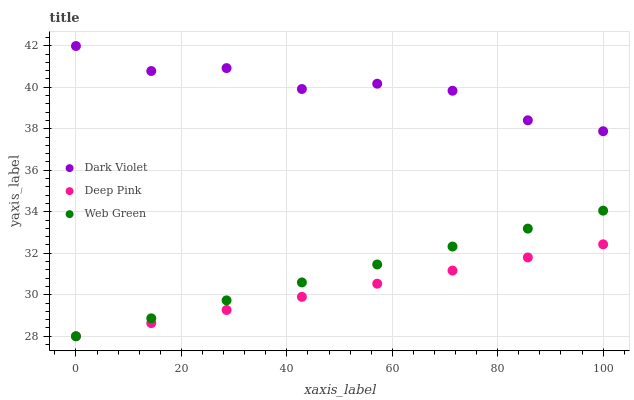Does Deep Pink have the minimum area under the curve?
Answer yes or no. Yes. Does Dark Violet have the maximum area under the curve?
Answer yes or no. Yes. Does Web Green have the minimum area under the curve?
Answer yes or no. No. Does Web Green have the maximum area under the curve?
Answer yes or no. No. Is Deep Pink the smoothest?
Answer yes or no. Yes. Is Dark Violet the roughest?
Answer yes or no. Yes. Is Web Green the smoothest?
Answer yes or no. No. Is Web Green the roughest?
Answer yes or no. No. Does Deep Pink have the lowest value?
Answer yes or no. Yes. Does Dark Violet have the lowest value?
Answer yes or no. No. Does Dark Violet have the highest value?
Answer yes or no. Yes. Does Web Green have the highest value?
Answer yes or no. No. Is Web Green less than Dark Violet?
Answer yes or no. Yes. Is Dark Violet greater than Deep Pink?
Answer yes or no. Yes. Does Deep Pink intersect Web Green?
Answer yes or no. Yes. Is Deep Pink less than Web Green?
Answer yes or no. No. Is Deep Pink greater than Web Green?
Answer yes or no. No. Does Web Green intersect Dark Violet?
Answer yes or no. No. 